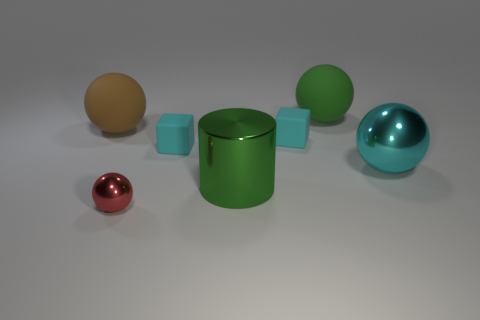What is the color of the matte ball that is the same size as the brown matte thing?
Offer a terse response. Green. Are the big cyan sphere that is behind the big green metallic thing and the big sphere left of the green ball made of the same material?
Offer a terse response. No. There is a matte ball that is on the right side of the large green thing that is in front of the large brown matte ball; how big is it?
Keep it short and to the point. Large. There is a small object that is in front of the big metal cylinder; what is it made of?
Keep it short and to the point. Metal. How many things are either large things that are behind the big brown ball or metal things that are to the left of the large green sphere?
Your answer should be very brief. 3. There is a large cyan thing that is the same shape as the tiny red shiny object; what material is it?
Give a very brief answer. Metal. Do the large sphere that is behind the large brown ball and the big metal object that is in front of the big cyan sphere have the same color?
Give a very brief answer. Yes. Are there any other green objects of the same size as the green matte thing?
Give a very brief answer. Yes. There is a sphere that is in front of the brown sphere and behind the red shiny sphere; what material is it made of?
Your answer should be very brief. Metal. How many matte things are either gray objects or cyan blocks?
Provide a short and direct response. 2. 